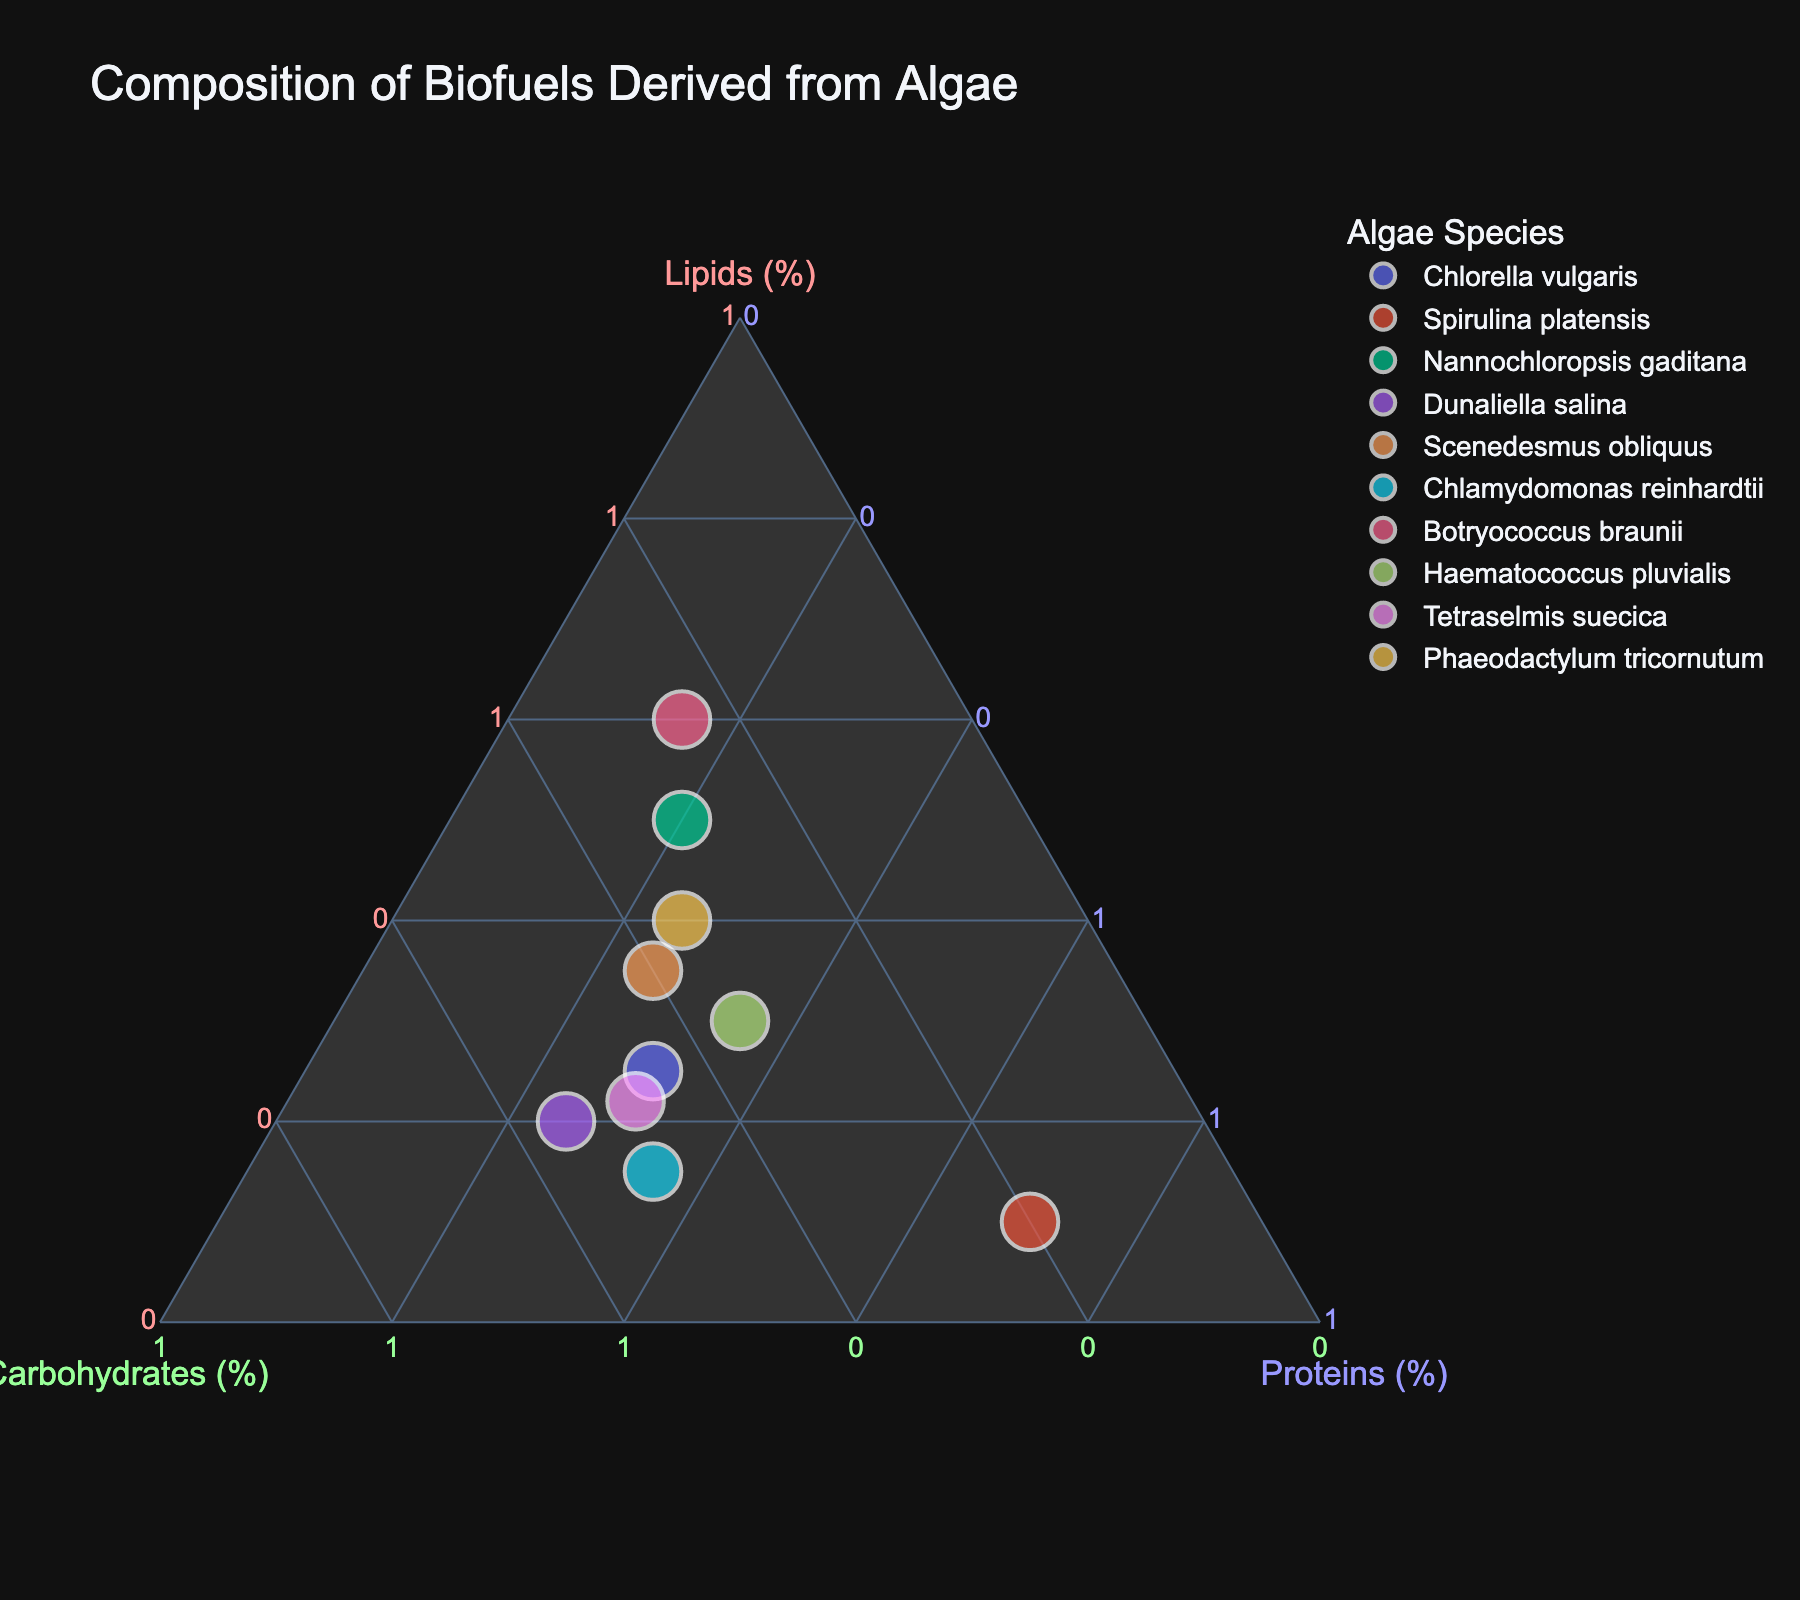How many algae species are represented in the plot? By observing the plot, we can count the number of unique data points, each corresponding to a different algae species.
Answer: 10 Which algae species has the highest proportion of lipids? The species positioned closest to the "Lipids" vertex of the ternary plot will have the highest proportion of lipids. In this case, it's Botryococcus braunii.
Answer: Botryococcus braunii What is the proportion of proteins for Chlamydomonas reinhardtii? By locating Chlamydomonas reinhardtii on the plot and referring to the "Proteins" axis, we can see that the proportion of proteins is 35%.
Answer: 35% Which two algae species have similar proportions of lipids and carbohydrates but differ significantly in proteins? By analyzing the positioning of the data points in relation to the "Lipids" and "Carbohydrates" vertices, we can identify Haematococcus pluvialis and Chlorella vulgaris, which have similar lipids and carb contents but differ in proteins (35% vs. 30%).
Answer: Haematococcus pluvialis and Chlorella vulgaris What is the average proportion of carbohydrates across all algae species? Sum the carbohydrate proportions for all species (0.45 + 0.20 + 0.30 + 0.55 + 0.40 + 0.50 + 0.25 + 0.35 + 0.48 + 0.35 = 3.83) and divide by the number of species (10). Thus, the average is 3.83 / 10 = 0.383.
Answer: 0.383 Which algae species has the most balanced proportion of lipids, carbohydrates, and proteins? The species positioned closest to the center of the ternary plot would have the most balanced proportions. By examining the plot, Scenedesmus obliquus appears to be most balanced with fairly even proportions in each category.
Answer: Scenedesmus obliquus 